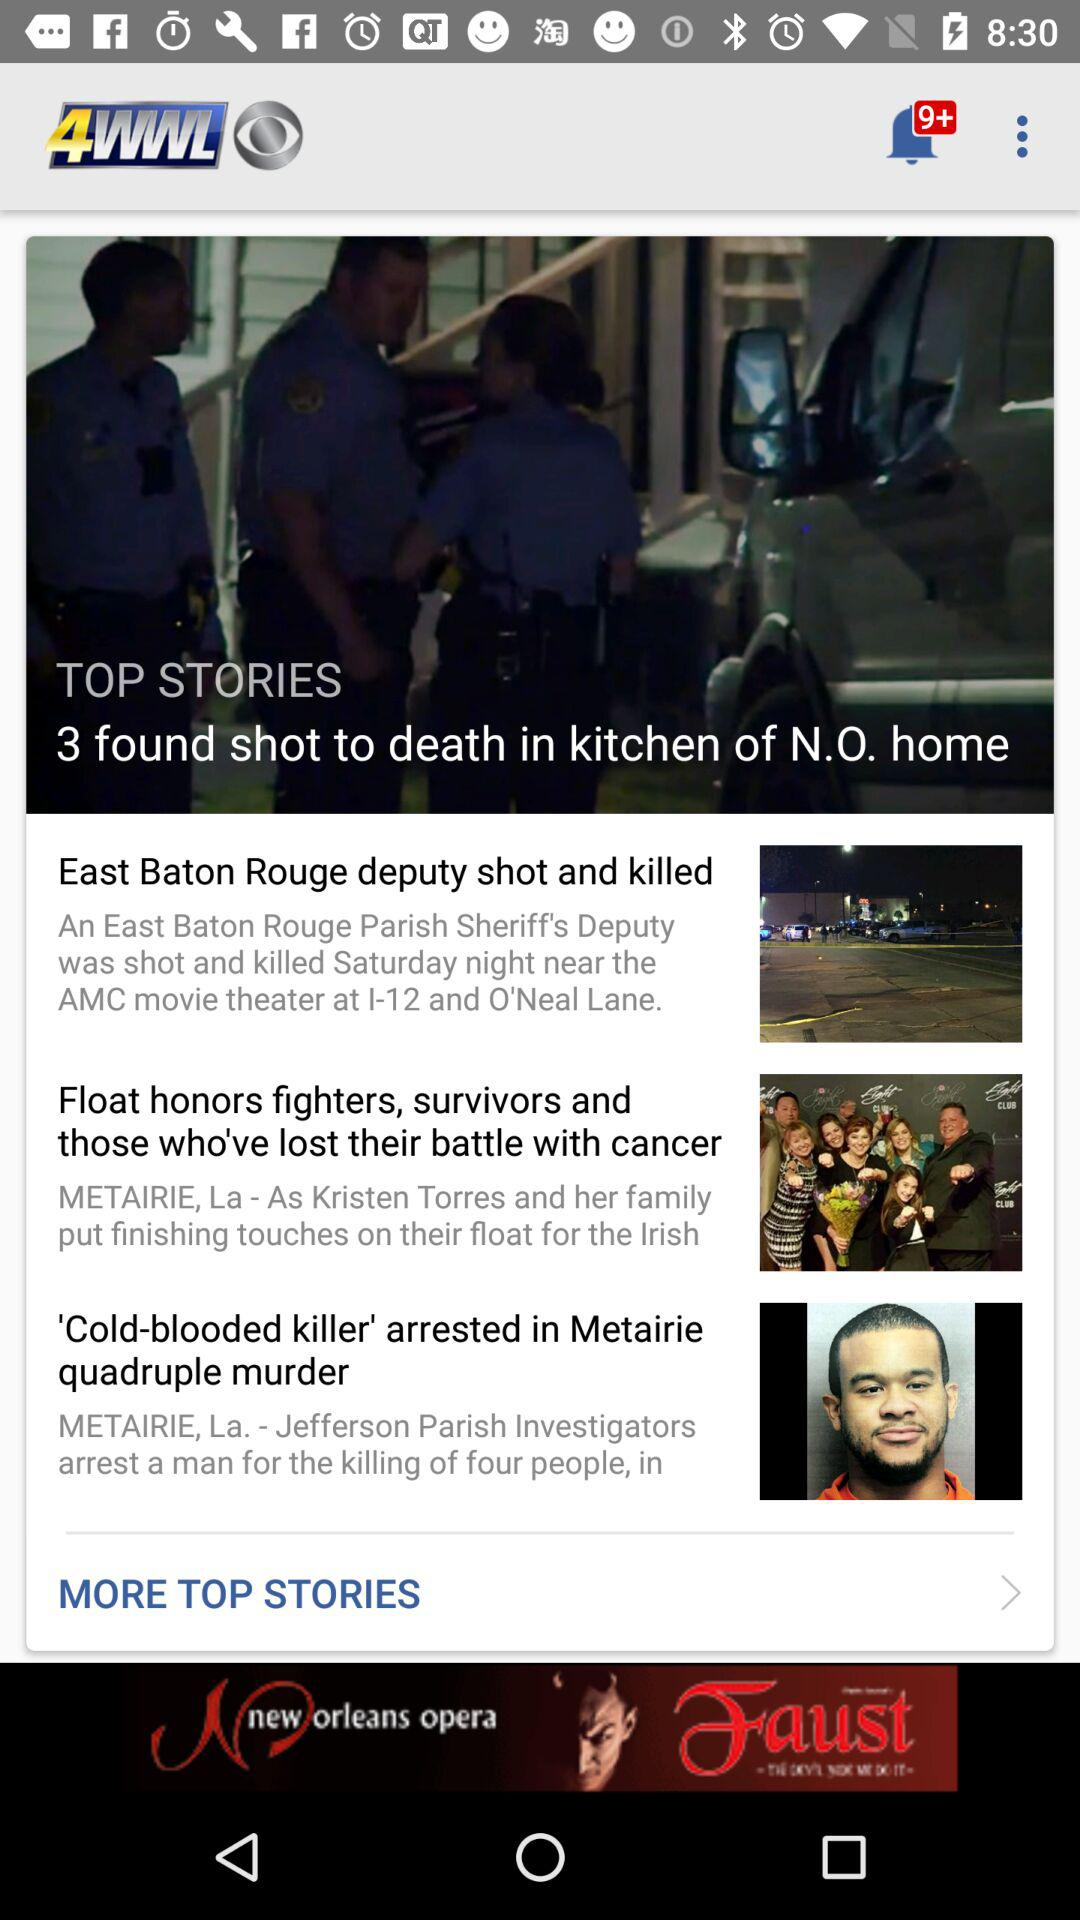What is the application name? The application name is "4WWL". 